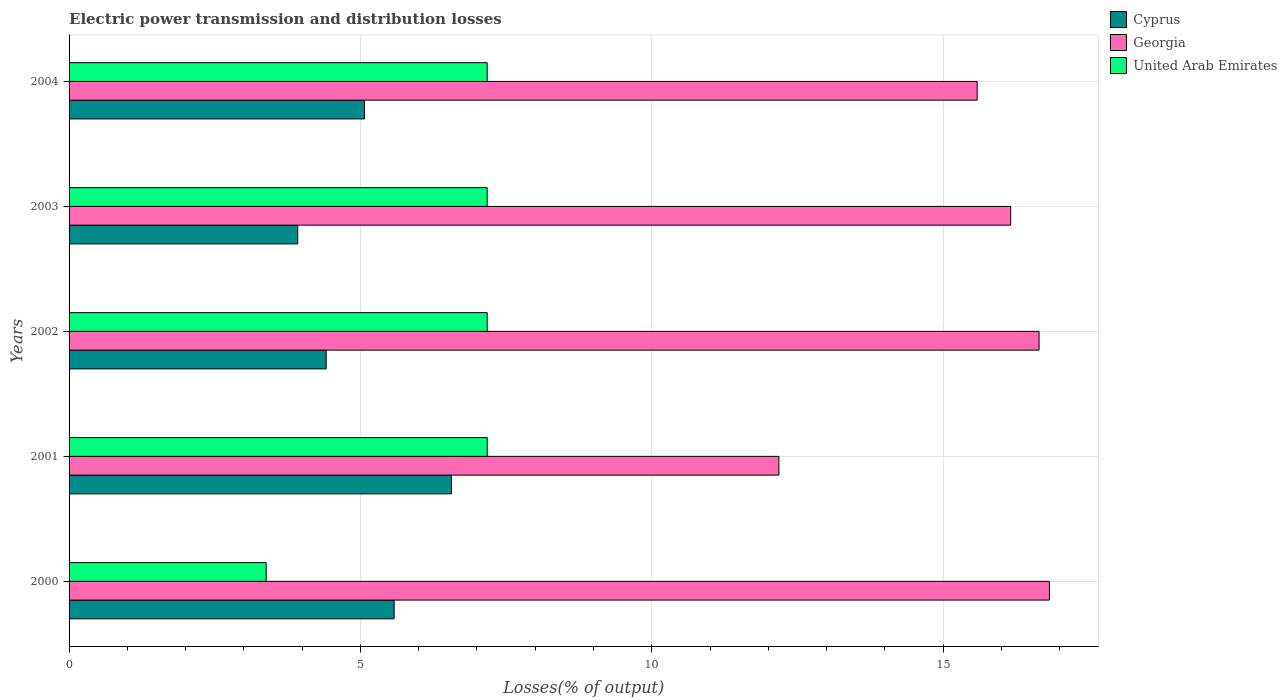How many different coloured bars are there?
Make the answer very short. 3. Are the number of bars per tick equal to the number of legend labels?
Offer a very short reply. Yes. Are the number of bars on each tick of the Y-axis equal?
Make the answer very short. Yes. What is the label of the 4th group of bars from the top?
Give a very brief answer. 2001. What is the electric power transmission and distribution losses in Cyprus in 2004?
Keep it short and to the point. 5.07. Across all years, what is the maximum electric power transmission and distribution losses in Cyprus?
Ensure brevity in your answer.  6.56. Across all years, what is the minimum electric power transmission and distribution losses in Cyprus?
Provide a succinct answer. 3.92. In which year was the electric power transmission and distribution losses in United Arab Emirates maximum?
Provide a succinct answer. 2001. In which year was the electric power transmission and distribution losses in Cyprus minimum?
Ensure brevity in your answer.  2003. What is the total electric power transmission and distribution losses in Georgia in the graph?
Your answer should be very brief. 77.39. What is the difference between the electric power transmission and distribution losses in Georgia in 2003 and that in 2004?
Your answer should be compact. 0.58. What is the difference between the electric power transmission and distribution losses in United Arab Emirates in 2004 and the electric power transmission and distribution losses in Cyprus in 2000?
Provide a succinct answer. 1.6. What is the average electric power transmission and distribution losses in Cyprus per year?
Offer a terse response. 5.11. In the year 2004, what is the difference between the electric power transmission and distribution losses in Cyprus and electric power transmission and distribution losses in Georgia?
Provide a succinct answer. -10.51. What is the ratio of the electric power transmission and distribution losses in Cyprus in 2003 to that in 2004?
Your answer should be very brief. 0.77. Is the electric power transmission and distribution losses in Georgia in 2000 less than that in 2002?
Keep it short and to the point. No. Is the difference between the electric power transmission and distribution losses in Cyprus in 2000 and 2003 greater than the difference between the electric power transmission and distribution losses in Georgia in 2000 and 2003?
Ensure brevity in your answer.  Yes. What is the difference between the highest and the second highest electric power transmission and distribution losses in Georgia?
Keep it short and to the point. 0.18. What is the difference between the highest and the lowest electric power transmission and distribution losses in Cyprus?
Provide a succinct answer. 2.64. In how many years, is the electric power transmission and distribution losses in Cyprus greater than the average electric power transmission and distribution losses in Cyprus taken over all years?
Your answer should be very brief. 2. What does the 3rd bar from the top in 2000 represents?
Your answer should be compact. Cyprus. What does the 1st bar from the bottom in 2003 represents?
Make the answer very short. Cyprus. How many bars are there?
Your answer should be compact. 15. Are all the bars in the graph horizontal?
Offer a very short reply. Yes. How many years are there in the graph?
Ensure brevity in your answer.  5. Are the values on the major ticks of X-axis written in scientific E-notation?
Provide a succinct answer. No. Does the graph contain any zero values?
Offer a terse response. No. How many legend labels are there?
Provide a succinct answer. 3. What is the title of the graph?
Ensure brevity in your answer.  Electric power transmission and distribution losses. What is the label or title of the X-axis?
Give a very brief answer. Losses(% of output). What is the label or title of the Y-axis?
Provide a short and direct response. Years. What is the Losses(% of output) in Cyprus in 2000?
Give a very brief answer. 5.58. What is the Losses(% of output) in Georgia in 2000?
Give a very brief answer. 16.82. What is the Losses(% of output) in United Arab Emirates in 2000?
Give a very brief answer. 3.38. What is the Losses(% of output) in Cyprus in 2001?
Make the answer very short. 6.56. What is the Losses(% of output) of Georgia in 2001?
Your response must be concise. 12.18. What is the Losses(% of output) in United Arab Emirates in 2001?
Provide a short and direct response. 7.18. What is the Losses(% of output) in Cyprus in 2002?
Offer a very short reply. 4.41. What is the Losses(% of output) in Georgia in 2002?
Your answer should be compact. 16.65. What is the Losses(% of output) in United Arab Emirates in 2002?
Give a very brief answer. 7.18. What is the Losses(% of output) of Cyprus in 2003?
Keep it short and to the point. 3.92. What is the Losses(% of output) in Georgia in 2003?
Make the answer very short. 16.16. What is the Losses(% of output) in United Arab Emirates in 2003?
Your response must be concise. 7.17. What is the Losses(% of output) in Cyprus in 2004?
Ensure brevity in your answer.  5.07. What is the Losses(% of output) of Georgia in 2004?
Provide a succinct answer. 15.58. What is the Losses(% of output) of United Arab Emirates in 2004?
Give a very brief answer. 7.18. Across all years, what is the maximum Losses(% of output) in Cyprus?
Offer a terse response. 6.56. Across all years, what is the maximum Losses(% of output) in Georgia?
Your answer should be compact. 16.82. Across all years, what is the maximum Losses(% of output) in United Arab Emirates?
Your answer should be compact. 7.18. Across all years, what is the minimum Losses(% of output) in Cyprus?
Your answer should be compact. 3.92. Across all years, what is the minimum Losses(% of output) of Georgia?
Provide a short and direct response. 12.18. Across all years, what is the minimum Losses(% of output) in United Arab Emirates?
Ensure brevity in your answer.  3.38. What is the total Losses(% of output) of Cyprus in the graph?
Make the answer very short. 25.55. What is the total Losses(% of output) of Georgia in the graph?
Your answer should be compact. 77.39. What is the total Losses(% of output) of United Arab Emirates in the graph?
Provide a short and direct response. 32.08. What is the difference between the Losses(% of output) of Cyprus in 2000 and that in 2001?
Your answer should be compact. -0.98. What is the difference between the Losses(% of output) in Georgia in 2000 and that in 2001?
Make the answer very short. 4.64. What is the difference between the Losses(% of output) of United Arab Emirates in 2000 and that in 2001?
Make the answer very short. -3.79. What is the difference between the Losses(% of output) in Cyprus in 2000 and that in 2002?
Keep it short and to the point. 1.17. What is the difference between the Losses(% of output) in Georgia in 2000 and that in 2002?
Provide a succinct answer. 0.18. What is the difference between the Losses(% of output) of United Arab Emirates in 2000 and that in 2002?
Provide a succinct answer. -3.79. What is the difference between the Losses(% of output) in Cyprus in 2000 and that in 2003?
Give a very brief answer. 1.65. What is the difference between the Losses(% of output) in Georgia in 2000 and that in 2003?
Provide a short and direct response. 0.66. What is the difference between the Losses(% of output) in United Arab Emirates in 2000 and that in 2003?
Ensure brevity in your answer.  -3.79. What is the difference between the Losses(% of output) in Cyprus in 2000 and that in 2004?
Give a very brief answer. 0.51. What is the difference between the Losses(% of output) of Georgia in 2000 and that in 2004?
Provide a succinct answer. 1.24. What is the difference between the Losses(% of output) of United Arab Emirates in 2000 and that in 2004?
Offer a terse response. -3.79. What is the difference between the Losses(% of output) of Cyprus in 2001 and that in 2002?
Your answer should be very brief. 2.15. What is the difference between the Losses(% of output) of Georgia in 2001 and that in 2002?
Your answer should be very brief. -4.46. What is the difference between the Losses(% of output) of United Arab Emirates in 2001 and that in 2002?
Offer a terse response. 0. What is the difference between the Losses(% of output) in Cyprus in 2001 and that in 2003?
Your response must be concise. 2.64. What is the difference between the Losses(% of output) in Georgia in 2001 and that in 2003?
Offer a terse response. -3.98. What is the difference between the Losses(% of output) in Cyprus in 2001 and that in 2004?
Make the answer very short. 1.49. What is the difference between the Losses(% of output) of Georgia in 2001 and that in 2004?
Your answer should be compact. -3.4. What is the difference between the Losses(% of output) in United Arab Emirates in 2001 and that in 2004?
Your answer should be compact. 0. What is the difference between the Losses(% of output) of Cyprus in 2002 and that in 2003?
Offer a very short reply. 0.49. What is the difference between the Losses(% of output) in Georgia in 2002 and that in 2003?
Ensure brevity in your answer.  0.49. What is the difference between the Losses(% of output) in United Arab Emirates in 2002 and that in 2003?
Make the answer very short. 0. What is the difference between the Losses(% of output) in Cyprus in 2002 and that in 2004?
Offer a terse response. -0.66. What is the difference between the Losses(% of output) in Cyprus in 2003 and that in 2004?
Keep it short and to the point. -1.15. What is the difference between the Losses(% of output) of Georgia in 2003 and that in 2004?
Ensure brevity in your answer.  0.58. What is the difference between the Losses(% of output) in United Arab Emirates in 2003 and that in 2004?
Your answer should be compact. -0. What is the difference between the Losses(% of output) of Cyprus in 2000 and the Losses(% of output) of Georgia in 2001?
Make the answer very short. -6.6. What is the difference between the Losses(% of output) in Cyprus in 2000 and the Losses(% of output) in United Arab Emirates in 2001?
Keep it short and to the point. -1.6. What is the difference between the Losses(% of output) in Georgia in 2000 and the Losses(% of output) in United Arab Emirates in 2001?
Keep it short and to the point. 9.65. What is the difference between the Losses(% of output) of Cyprus in 2000 and the Losses(% of output) of Georgia in 2002?
Give a very brief answer. -11.07. What is the difference between the Losses(% of output) of Cyprus in 2000 and the Losses(% of output) of United Arab Emirates in 2002?
Give a very brief answer. -1.6. What is the difference between the Losses(% of output) in Georgia in 2000 and the Losses(% of output) in United Arab Emirates in 2002?
Offer a very short reply. 9.65. What is the difference between the Losses(% of output) in Cyprus in 2000 and the Losses(% of output) in Georgia in 2003?
Provide a succinct answer. -10.58. What is the difference between the Losses(% of output) of Cyprus in 2000 and the Losses(% of output) of United Arab Emirates in 2003?
Your answer should be very brief. -1.6. What is the difference between the Losses(% of output) of Georgia in 2000 and the Losses(% of output) of United Arab Emirates in 2003?
Give a very brief answer. 9.65. What is the difference between the Losses(% of output) of Cyprus in 2000 and the Losses(% of output) of Georgia in 2004?
Your response must be concise. -10. What is the difference between the Losses(% of output) of Cyprus in 2000 and the Losses(% of output) of United Arab Emirates in 2004?
Offer a very short reply. -1.6. What is the difference between the Losses(% of output) of Georgia in 2000 and the Losses(% of output) of United Arab Emirates in 2004?
Provide a short and direct response. 9.65. What is the difference between the Losses(% of output) of Cyprus in 2001 and the Losses(% of output) of Georgia in 2002?
Your answer should be compact. -10.08. What is the difference between the Losses(% of output) of Cyprus in 2001 and the Losses(% of output) of United Arab Emirates in 2002?
Your answer should be very brief. -0.61. What is the difference between the Losses(% of output) in Georgia in 2001 and the Losses(% of output) in United Arab Emirates in 2002?
Keep it short and to the point. 5.01. What is the difference between the Losses(% of output) in Cyprus in 2001 and the Losses(% of output) in Georgia in 2003?
Your answer should be very brief. -9.6. What is the difference between the Losses(% of output) in Cyprus in 2001 and the Losses(% of output) in United Arab Emirates in 2003?
Ensure brevity in your answer.  -0.61. What is the difference between the Losses(% of output) of Georgia in 2001 and the Losses(% of output) of United Arab Emirates in 2003?
Ensure brevity in your answer.  5.01. What is the difference between the Losses(% of output) in Cyprus in 2001 and the Losses(% of output) in Georgia in 2004?
Make the answer very short. -9.02. What is the difference between the Losses(% of output) of Cyprus in 2001 and the Losses(% of output) of United Arab Emirates in 2004?
Provide a short and direct response. -0.61. What is the difference between the Losses(% of output) in Georgia in 2001 and the Losses(% of output) in United Arab Emirates in 2004?
Make the answer very short. 5.01. What is the difference between the Losses(% of output) in Cyprus in 2002 and the Losses(% of output) in Georgia in 2003?
Keep it short and to the point. -11.75. What is the difference between the Losses(% of output) in Cyprus in 2002 and the Losses(% of output) in United Arab Emirates in 2003?
Your answer should be very brief. -2.76. What is the difference between the Losses(% of output) in Georgia in 2002 and the Losses(% of output) in United Arab Emirates in 2003?
Give a very brief answer. 9.47. What is the difference between the Losses(% of output) in Cyprus in 2002 and the Losses(% of output) in Georgia in 2004?
Keep it short and to the point. -11.17. What is the difference between the Losses(% of output) of Cyprus in 2002 and the Losses(% of output) of United Arab Emirates in 2004?
Provide a short and direct response. -2.76. What is the difference between the Losses(% of output) of Georgia in 2002 and the Losses(% of output) of United Arab Emirates in 2004?
Make the answer very short. 9.47. What is the difference between the Losses(% of output) of Cyprus in 2003 and the Losses(% of output) of Georgia in 2004?
Offer a terse response. -11.66. What is the difference between the Losses(% of output) of Cyprus in 2003 and the Losses(% of output) of United Arab Emirates in 2004?
Provide a succinct answer. -3.25. What is the difference between the Losses(% of output) in Georgia in 2003 and the Losses(% of output) in United Arab Emirates in 2004?
Give a very brief answer. 8.98. What is the average Losses(% of output) in Cyprus per year?
Offer a very short reply. 5.11. What is the average Losses(% of output) in Georgia per year?
Provide a succinct answer. 15.48. What is the average Losses(% of output) of United Arab Emirates per year?
Offer a very short reply. 6.42. In the year 2000, what is the difference between the Losses(% of output) of Cyprus and Losses(% of output) of Georgia?
Provide a short and direct response. -11.25. In the year 2000, what is the difference between the Losses(% of output) in Cyprus and Losses(% of output) in United Arab Emirates?
Offer a very short reply. 2.2. In the year 2000, what is the difference between the Losses(% of output) of Georgia and Losses(% of output) of United Arab Emirates?
Give a very brief answer. 13.44. In the year 2001, what is the difference between the Losses(% of output) of Cyprus and Losses(% of output) of Georgia?
Ensure brevity in your answer.  -5.62. In the year 2001, what is the difference between the Losses(% of output) in Cyprus and Losses(% of output) in United Arab Emirates?
Offer a very short reply. -0.61. In the year 2001, what is the difference between the Losses(% of output) of Georgia and Losses(% of output) of United Arab Emirates?
Offer a terse response. 5.01. In the year 2002, what is the difference between the Losses(% of output) of Cyprus and Losses(% of output) of Georgia?
Make the answer very short. -12.23. In the year 2002, what is the difference between the Losses(% of output) in Cyprus and Losses(% of output) in United Arab Emirates?
Offer a very short reply. -2.76. In the year 2002, what is the difference between the Losses(% of output) of Georgia and Losses(% of output) of United Arab Emirates?
Ensure brevity in your answer.  9.47. In the year 2003, what is the difference between the Losses(% of output) in Cyprus and Losses(% of output) in Georgia?
Ensure brevity in your answer.  -12.24. In the year 2003, what is the difference between the Losses(% of output) in Cyprus and Losses(% of output) in United Arab Emirates?
Your response must be concise. -3.25. In the year 2003, what is the difference between the Losses(% of output) in Georgia and Losses(% of output) in United Arab Emirates?
Offer a terse response. 8.98. In the year 2004, what is the difference between the Losses(% of output) in Cyprus and Losses(% of output) in Georgia?
Your response must be concise. -10.51. In the year 2004, what is the difference between the Losses(% of output) in Cyprus and Losses(% of output) in United Arab Emirates?
Ensure brevity in your answer.  -2.1. In the year 2004, what is the difference between the Losses(% of output) in Georgia and Losses(% of output) in United Arab Emirates?
Ensure brevity in your answer.  8.41. What is the ratio of the Losses(% of output) of Cyprus in 2000 to that in 2001?
Keep it short and to the point. 0.85. What is the ratio of the Losses(% of output) in Georgia in 2000 to that in 2001?
Provide a short and direct response. 1.38. What is the ratio of the Losses(% of output) of United Arab Emirates in 2000 to that in 2001?
Keep it short and to the point. 0.47. What is the ratio of the Losses(% of output) of Cyprus in 2000 to that in 2002?
Your answer should be compact. 1.26. What is the ratio of the Losses(% of output) in Georgia in 2000 to that in 2002?
Your response must be concise. 1.01. What is the ratio of the Losses(% of output) in United Arab Emirates in 2000 to that in 2002?
Provide a short and direct response. 0.47. What is the ratio of the Losses(% of output) of Cyprus in 2000 to that in 2003?
Your answer should be very brief. 1.42. What is the ratio of the Losses(% of output) in Georgia in 2000 to that in 2003?
Your response must be concise. 1.04. What is the ratio of the Losses(% of output) in United Arab Emirates in 2000 to that in 2003?
Give a very brief answer. 0.47. What is the ratio of the Losses(% of output) in Cyprus in 2000 to that in 2004?
Ensure brevity in your answer.  1.1. What is the ratio of the Losses(% of output) in Georgia in 2000 to that in 2004?
Provide a succinct answer. 1.08. What is the ratio of the Losses(% of output) in United Arab Emirates in 2000 to that in 2004?
Offer a terse response. 0.47. What is the ratio of the Losses(% of output) of Cyprus in 2001 to that in 2002?
Your answer should be very brief. 1.49. What is the ratio of the Losses(% of output) in Georgia in 2001 to that in 2002?
Make the answer very short. 0.73. What is the ratio of the Losses(% of output) in Cyprus in 2001 to that in 2003?
Keep it short and to the point. 1.67. What is the ratio of the Losses(% of output) in Georgia in 2001 to that in 2003?
Your answer should be very brief. 0.75. What is the ratio of the Losses(% of output) of United Arab Emirates in 2001 to that in 2003?
Offer a very short reply. 1. What is the ratio of the Losses(% of output) in Cyprus in 2001 to that in 2004?
Keep it short and to the point. 1.29. What is the ratio of the Losses(% of output) in Georgia in 2001 to that in 2004?
Ensure brevity in your answer.  0.78. What is the ratio of the Losses(% of output) in Cyprus in 2002 to that in 2003?
Your answer should be very brief. 1.12. What is the ratio of the Losses(% of output) in Georgia in 2002 to that in 2003?
Give a very brief answer. 1.03. What is the ratio of the Losses(% of output) in Cyprus in 2002 to that in 2004?
Offer a terse response. 0.87. What is the ratio of the Losses(% of output) of Georgia in 2002 to that in 2004?
Offer a terse response. 1.07. What is the ratio of the Losses(% of output) of United Arab Emirates in 2002 to that in 2004?
Ensure brevity in your answer.  1. What is the ratio of the Losses(% of output) of Cyprus in 2003 to that in 2004?
Provide a succinct answer. 0.77. What is the ratio of the Losses(% of output) in Georgia in 2003 to that in 2004?
Provide a short and direct response. 1.04. What is the ratio of the Losses(% of output) in United Arab Emirates in 2003 to that in 2004?
Your answer should be compact. 1. What is the difference between the highest and the second highest Losses(% of output) of Cyprus?
Your answer should be compact. 0.98. What is the difference between the highest and the second highest Losses(% of output) of Georgia?
Your answer should be very brief. 0.18. What is the difference between the highest and the second highest Losses(% of output) in United Arab Emirates?
Keep it short and to the point. 0. What is the difference between the highest and the lowest Losses(% of output) in Cyprus?
Your response must be concise. 2.64. What is the difference between the highest and the lowest Losses(% of output) of Georgia?
Give a very brief answer. 4.64. What is the difference between the highest and the lowest Losses(% of output) in United Arab Emirates?
Offer a terse response. 3.79. 